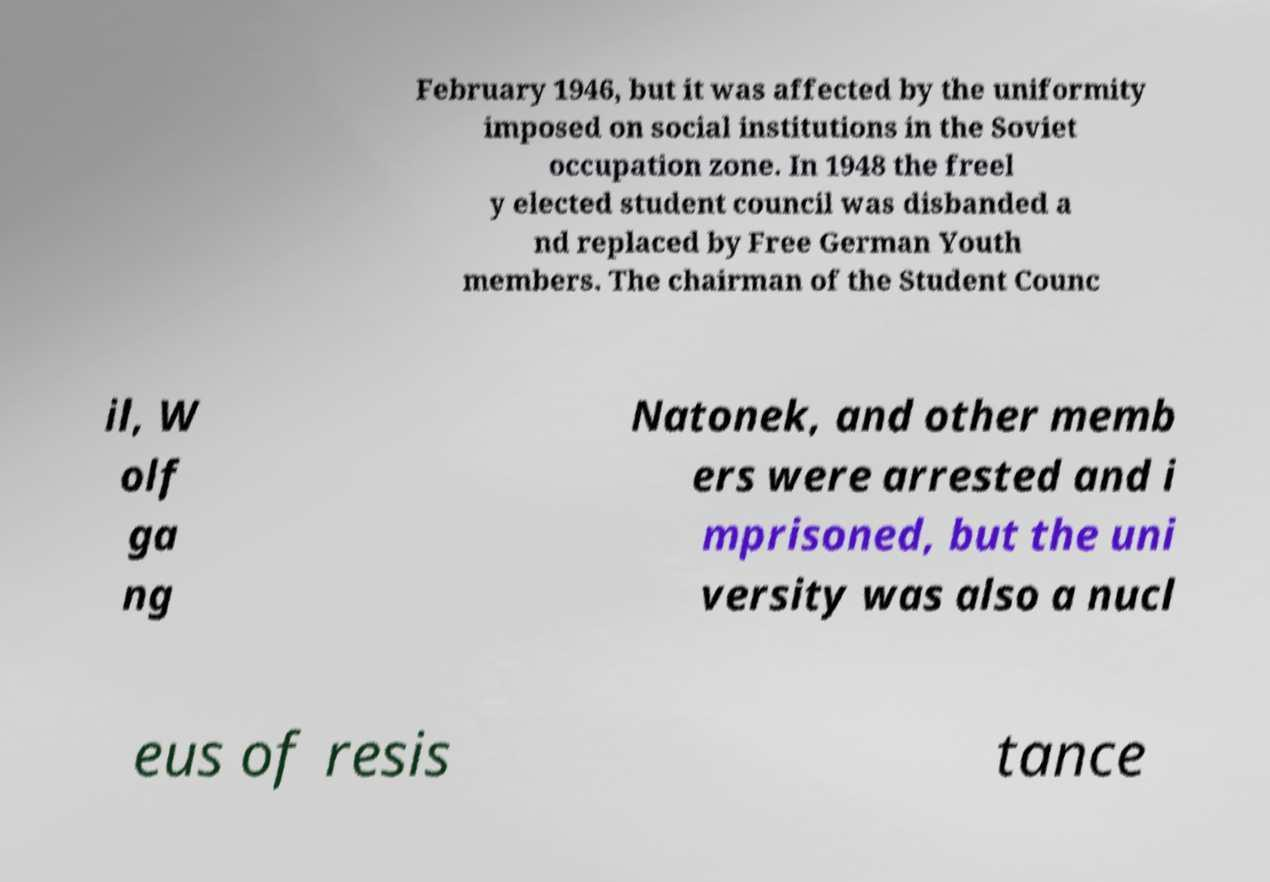Please identify and transcribe the text found in this image. February 1946, but it was affected by the uniformity imposed on social institutions in the Soviet occupation zone. In 1948 the freel y elected student council was disbanded a nd replaced by Free German Youth members. The chairman of the Student Counc il, W olf ga ng Natonek, and other memb ers were arrested and i mprisoned, but the uni versity was also a nucl eus of resis tance 